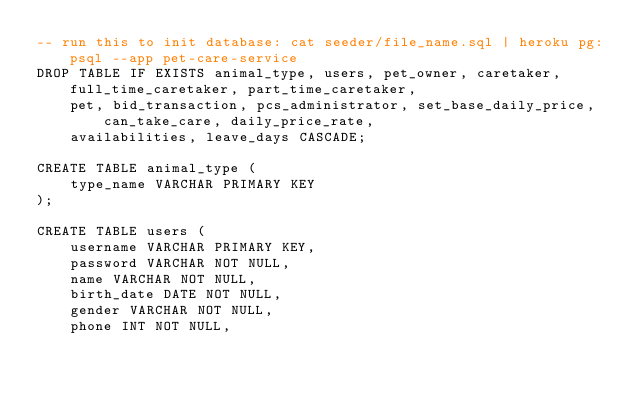<code> <loc_0><loc_0><loc_500><loc_500><_SQL_>-- run this to init database: cat seeder/file_name.sql | heroku pg:psql --app pet-care-service
DROP TABLE IF EXISTS animal_type, users, pet_owner, caretaker, full_time_caretaker, part_time_caretaker, 
	pet, bid_transaction, pcs_administrator, set_base_daily_price, can_take_care, daily_price_rate,
	availabilities, leave_days CASCADE;

CREATE TABLE animal_type (
	type_name VARCHAR PRIMARY KEY
);

CREATE TABLE users (
    username VARCHAR PRIMARY KEY,
	password VARCHAR NOT NULL,
	name VARCHAR NOT NULL,
	birth_date DATE NOT NULL,
	gender VARCHAR NOT NULL, 
	phone INT NOT NULL,</code> 